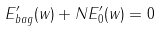Convert formula to latex. <formula><loc_0><loc_0><loc_500><loc_500>E _ { b a g } ^ { \prime } ( w ) + N E _ { 0 } ^ { \prime } ( w ) = 0</formula> 